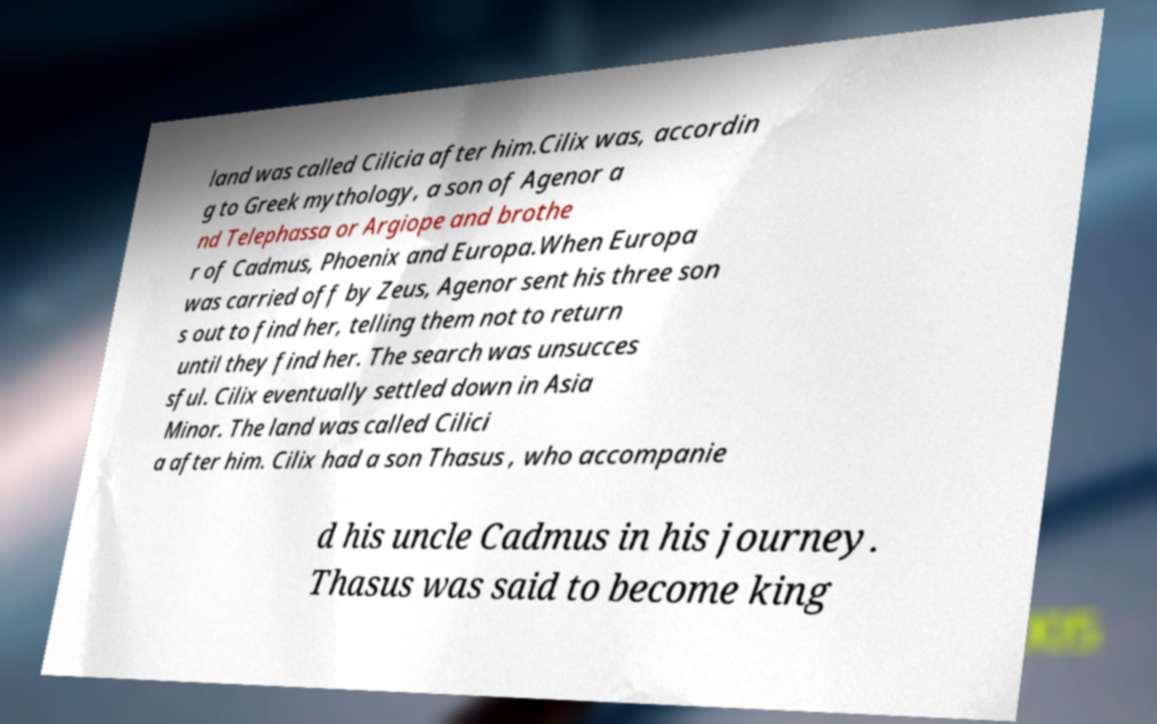There's text embedded in this image that I need extracted. Can you transcribe it verbatim? land was called Cilicia after him.Cilix was, accordin g to Greek mythology, a son of Agenor a nd Telephassa or Argiope and brothe r of Cadmus, Phoenix and Europa.When Europa was carried off by Zeus, Agenor sent his three son s out to find her, telling them not to return until they find her. The search was unsucces sful. Cilix eventually settled down in Asia Minor. The land was called Cilici a after him. Cilix had a son Thasus , who accompanie d his uncle Cadmus in his journey. Thasus was said to become king 